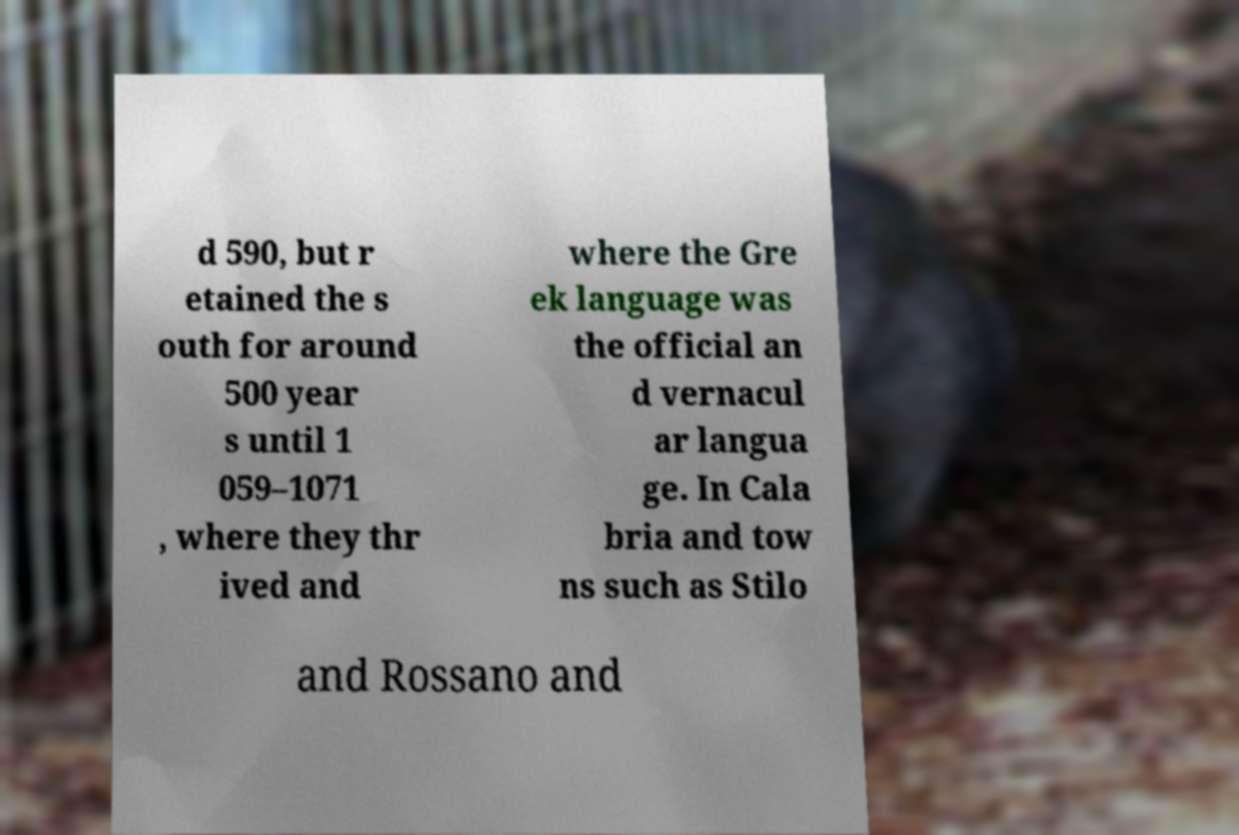Can you read and provide the text displayed in the image?This photo seems to have some interesting text. Can you extract and type it out for me? d 590, but r etained the s outh for around 500 year s until 1 059–1071 , where they thr ived and where the Gre ek language was the official an d vernacul ar langua ge. In Cala bria and tow ns such as Stilo and Rossano and 